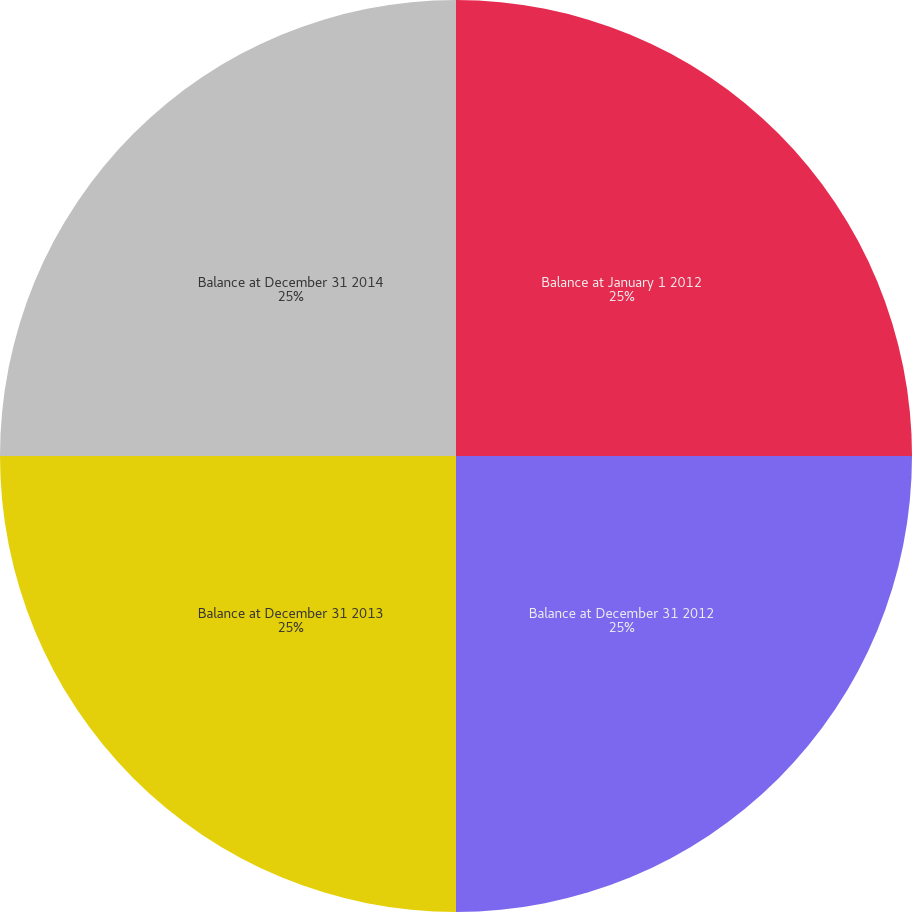Convert chart. <chart><loc_0><loc_0><loc_500><loc_500><pie_chart><fcel>Balance at January 1 2012<fcel>Balance at December 31 2012<fcel>Balance at December 31 2013<fcel>Balance at December 31 2014<nl><fcel>25.0%<fcel>25.0%<fcel>25.0%<fcel>25.0%<nl></chart> 